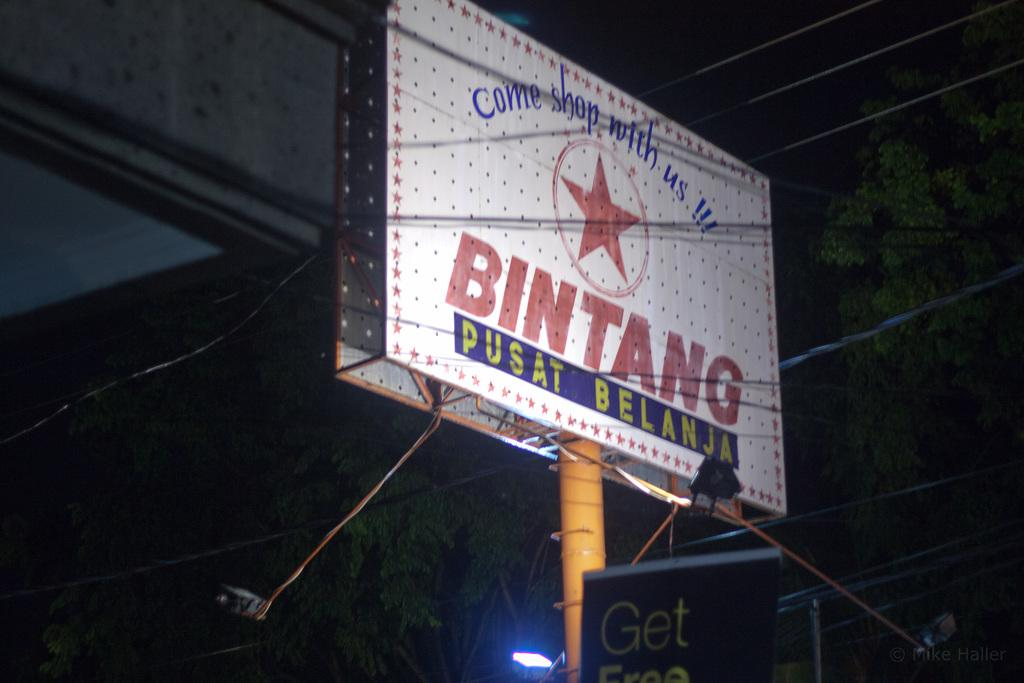<image>
Share a concise interpretation of the image provided. A billboard advises you to Come shop with us at Bintang Pusat Belanja. 